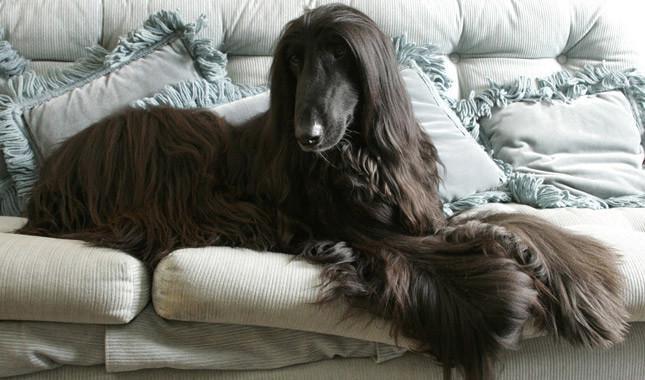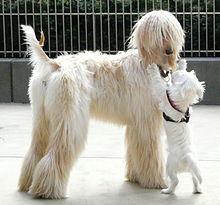The first image is the image on the left, the second image is the image on the right. For the images shown, is this caption "An image shows a dark-haired hound lounging on furniture with throw pillows." true? Answer yes or no. Yes. 